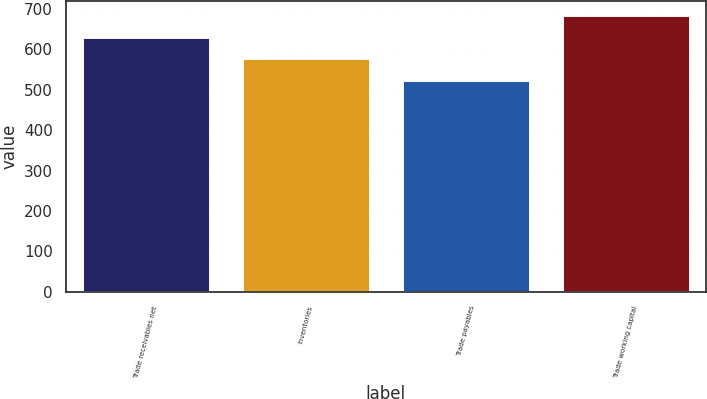<chart> <loc_0><loc_0><loc_500><loc_500><bar_chart><fcel>Trade receivables net<fcel>Inventories<fcel>Trade payables<fcel>Trade working capital<nl><fcel>631<fcel>577<fcel>523<fcel>685<nl></chart> 